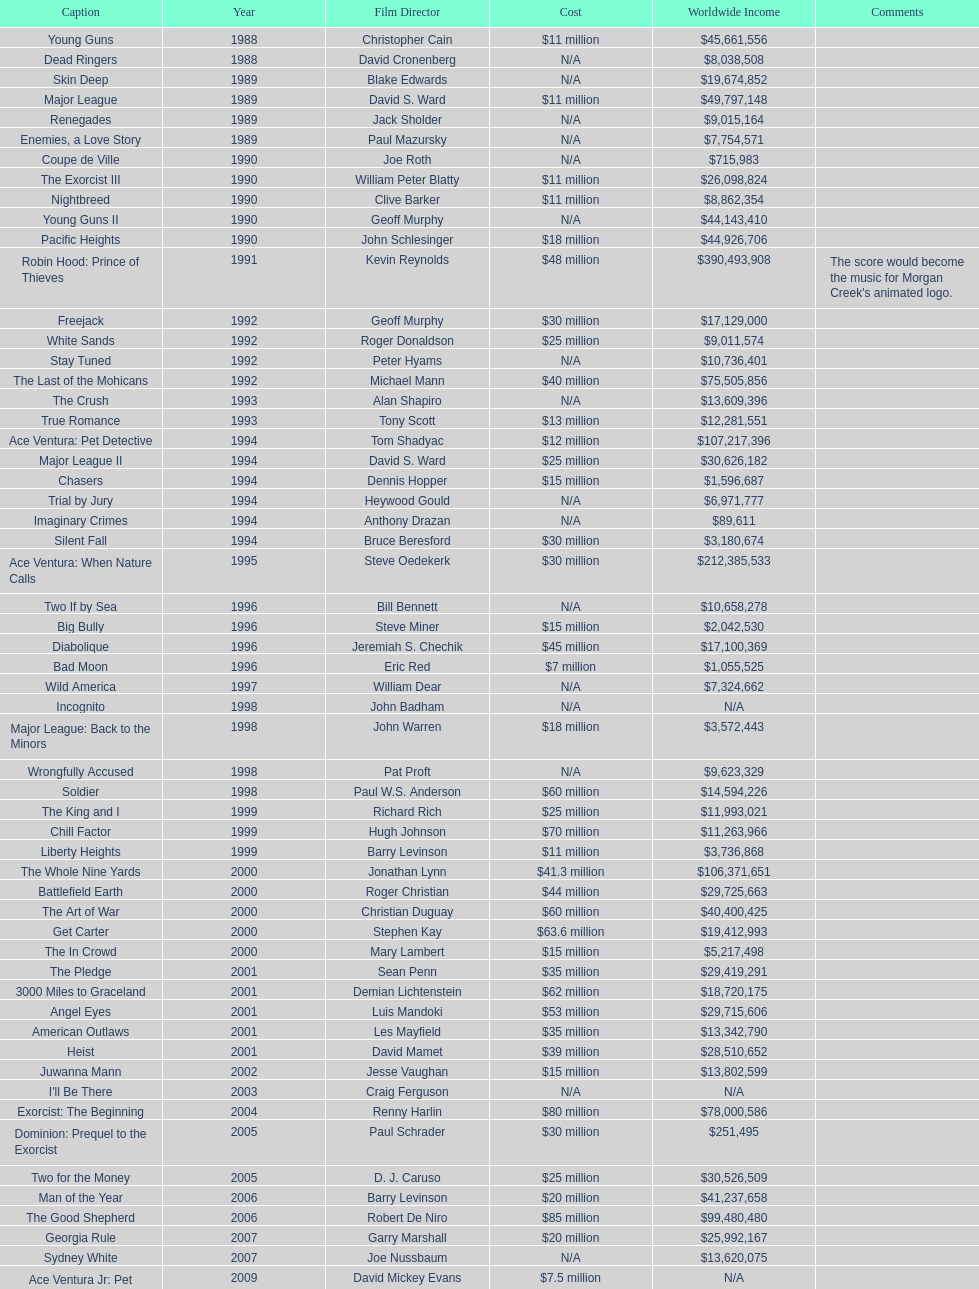Identify the only film with a budget set at 48 million dollars. Robin Hood: Prince of Thieves. 